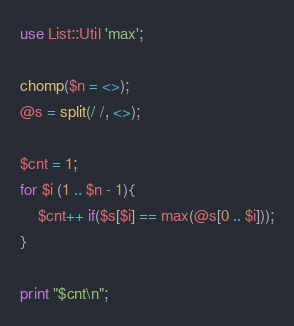Convert code to text. <code><loc_0><loc_0><loc_500><loc_500><_Perl_>use List::Util 'max';

chomp($n = <>);
@s = split(/ /, <>);

$cnt = 1;
for $i (1 .. $n - 1){
	$cnt++ if($s[$i] == max(@s[0 .. $i]));
}

print "$cnt\n";
</code> 